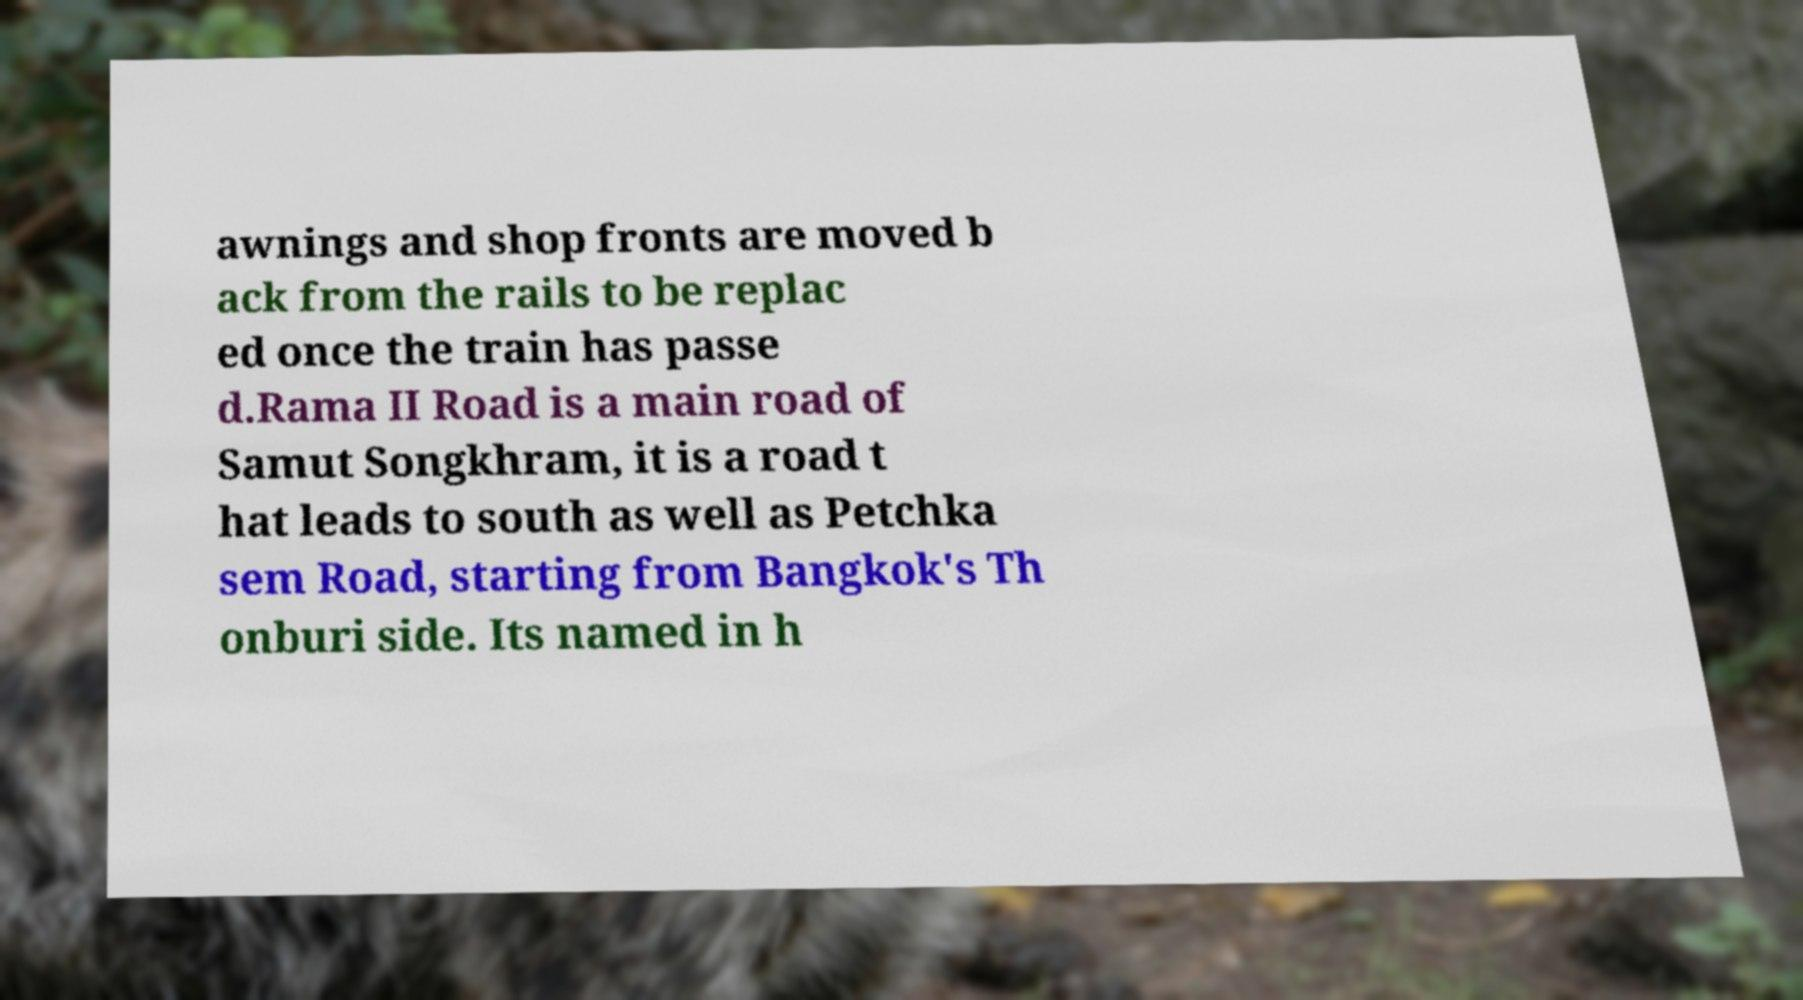What messages or text are displayed in this image? I need them in a readable, typed format. awnings and shop fronts are moved b ack from the rails to be replac ed once the train has passe d.Rama II Road is a main road of Samut Songkhram, it is a road t hat leads to south as well as Petchka sem Road, starting from Bangkok's Th onburi side. Its named in h 